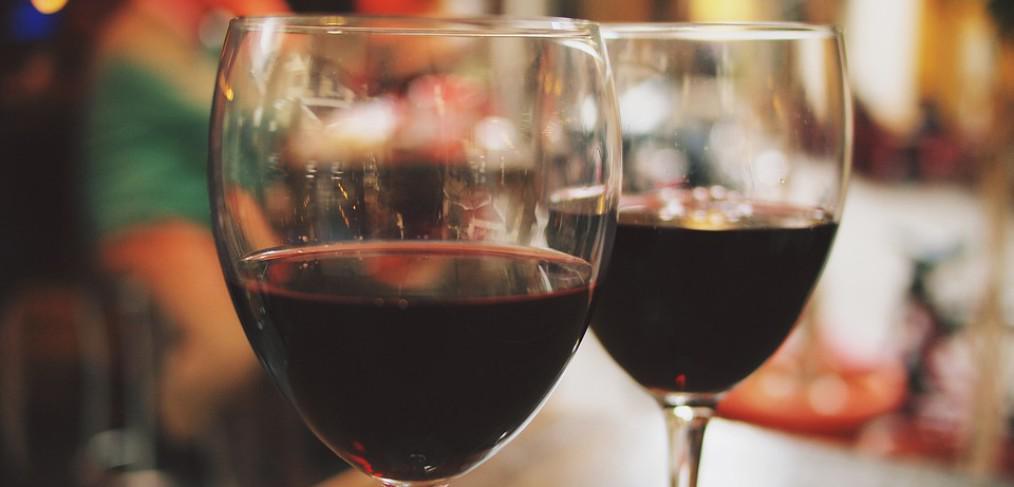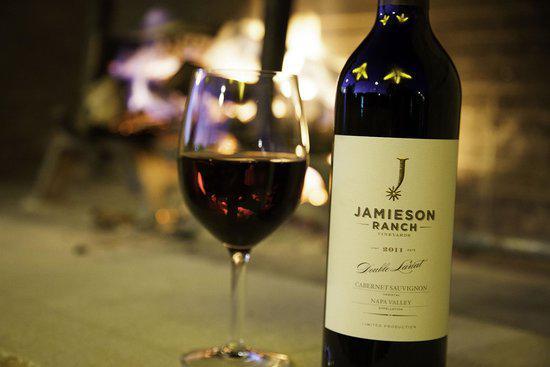The first image is the image on the left, the second image is the image on the right. Assess this claim about the two images: "In one of the images there are two wine glasses next to at least one bottle of wine and a bunch of grapes.". Correct or not? Answer yes or no. No. The first image is the image on the left, the second image is the image on the right. Evaluate the accuracy of this statement regarding the images: "At least one image shows a bunch of grapes near a glass partly filled with red wine.". Is it true? Answer yes or no. No. 